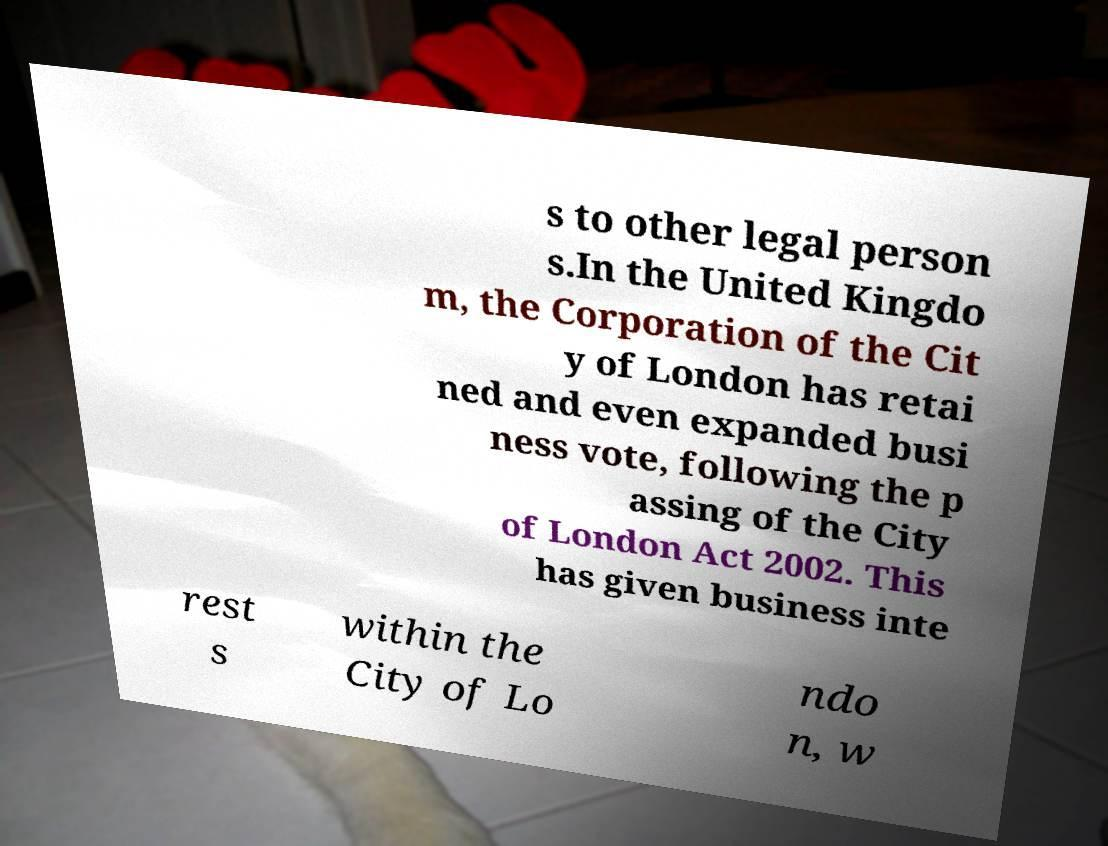There's text embedded in this image that I need extracted. Can you transcribe it verbatim? s to other legal person s.In the United Kingdo m, the Corporation of the Cit y of London has retai ned and even expanded busi ness vote, following the p assing of the City of London Act 2002. This has given business inte rest s within the City of Lo ndo n, w 